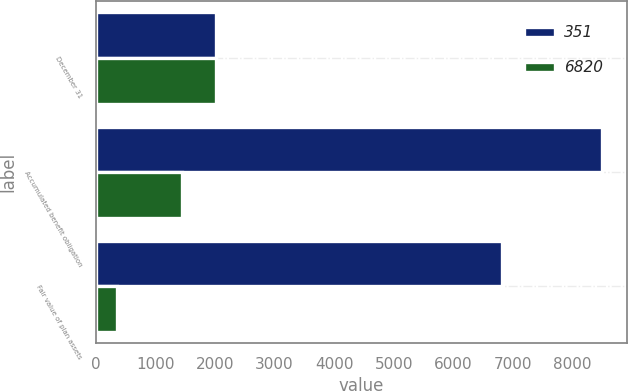Convert chart to OTSL. <chart><loc_0><loc_0><loc_500><loc_500><stacked_bar_chart><ecel><fcel>December 31<fcel>Accumulated benefit obligation<fcel>Fair value of plan assets<nl><fcel>351<fcel>2014<fcel>8501<fcel>6820<nl><fcel>6820<fcel>2013<fcel>1446<fcel>351<nl></chart> 